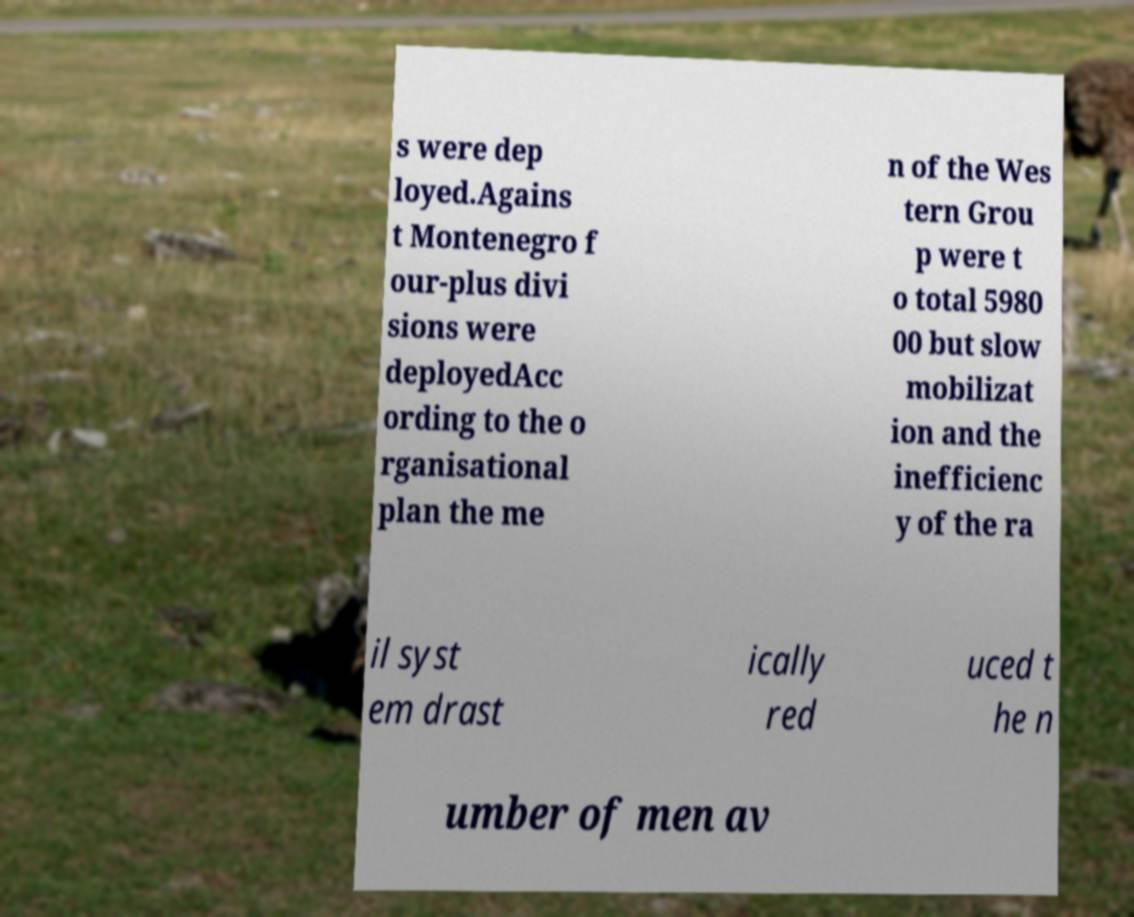I need the written content from this picture converted into text. Can you do that? s were dep loyed.Agains t Montenegro f our-plus divi sions were deployedAcc ording to the o rganisational plan the me n of the Wes tern Grou p were t o total 5980 00 but slow mobilizat ion and the inefficienc y of the ra il syst em drast ically red uced t he n umber of men av 